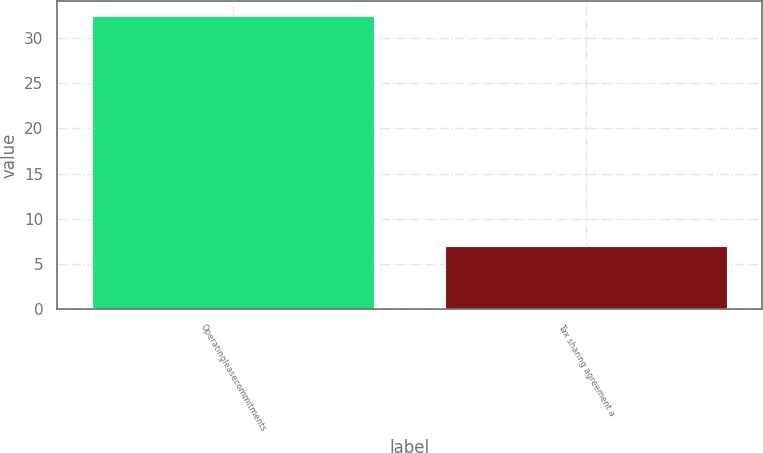Convert chart to OTSL. <chart><loc_0><loc_0><loc_500><loc_500><bar_chart><fcel>Operatingleasecommitments<fcel>Tax sharing agreement a<nl><fcel>32.4<fcel>7<nl></chart> 